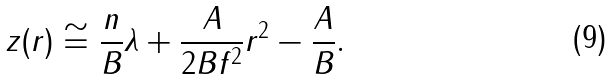Convert formula to latex. <formula><loc_0><loc_0><loc_500><loc_500>z ( r ) \cong \frac { n } { B } \lambda + \frac { A } { 2 B f ^ { 2 } } r ^ { 2 } - \frac { A } { B } .</formula> 